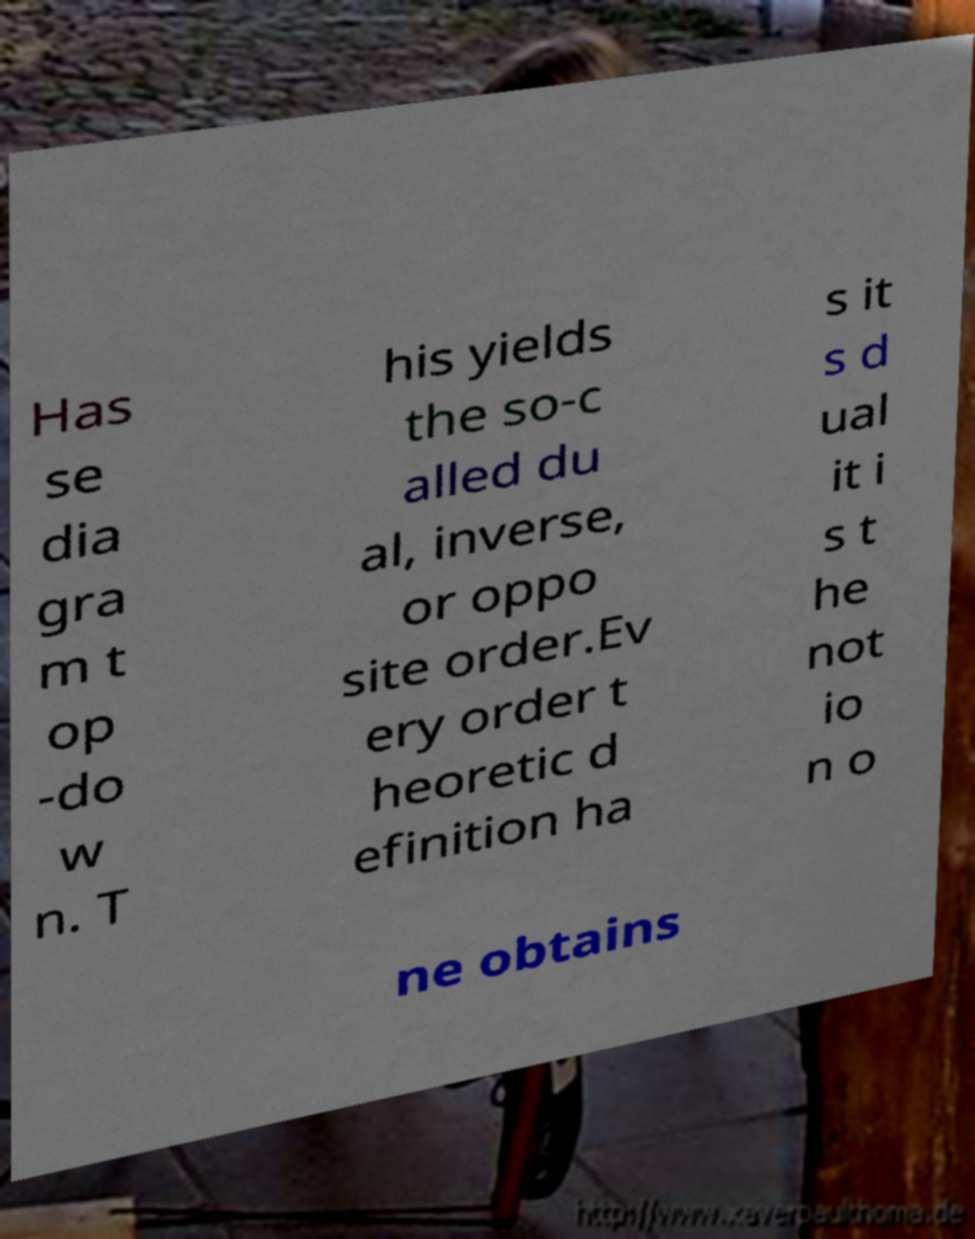Could you extract and type out the text from this image? Has se dia gra m t op -do w n. T his yields the so-c alled du al, inverse, or oppo site order.Ev ery order t heoretic d efinition ha s it s d ual it i s t he not io n o ne obtains 